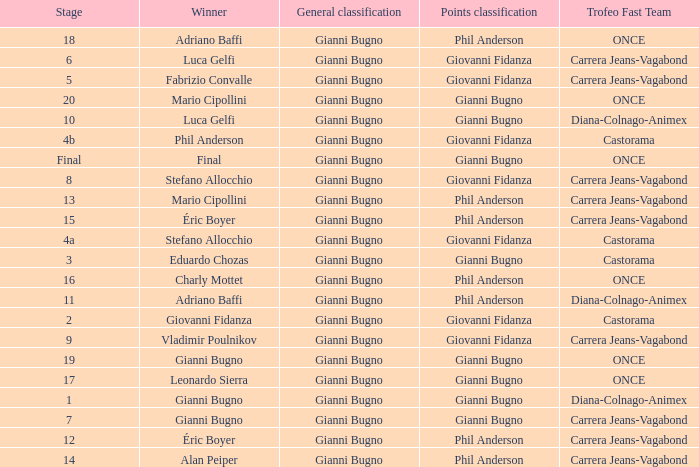What is the stage when the winner is charly mottet? 16.0. 